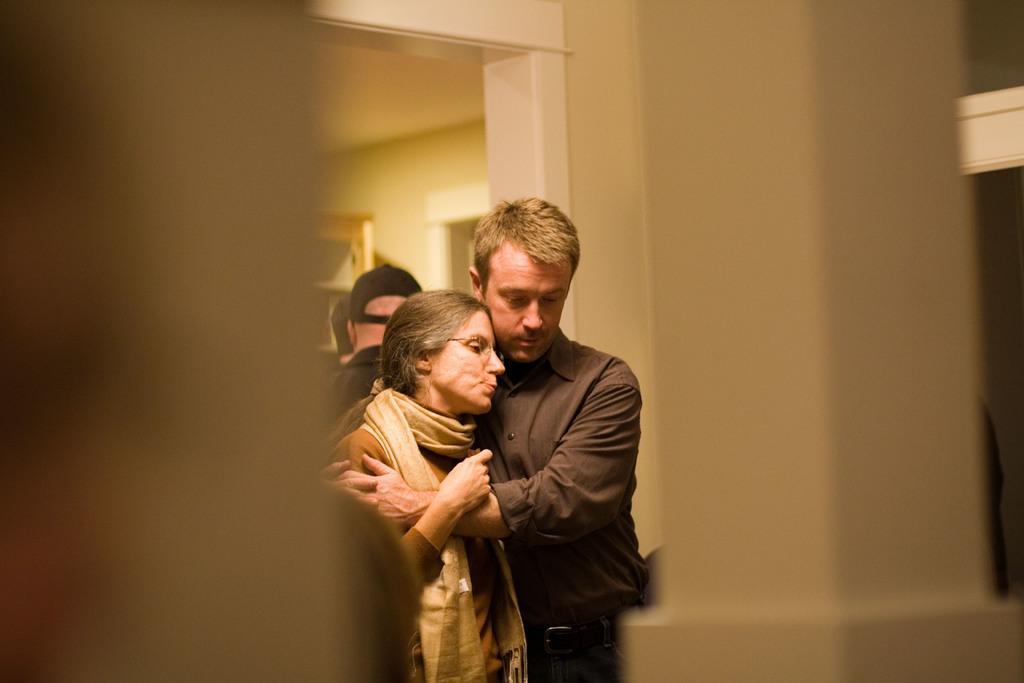Describe this image in one or two sentences. In this picture I can see a man and woman hugging. I can see a few people in the background. 